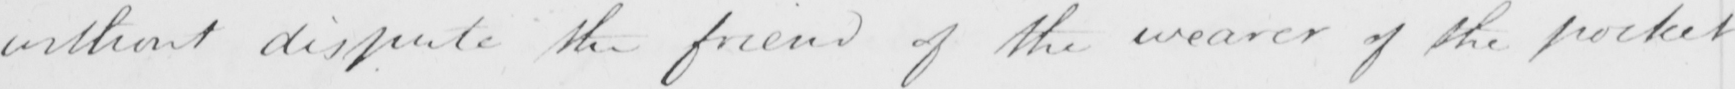What does this handwritten line say? without dispute the friend of the wearer of the pocket 